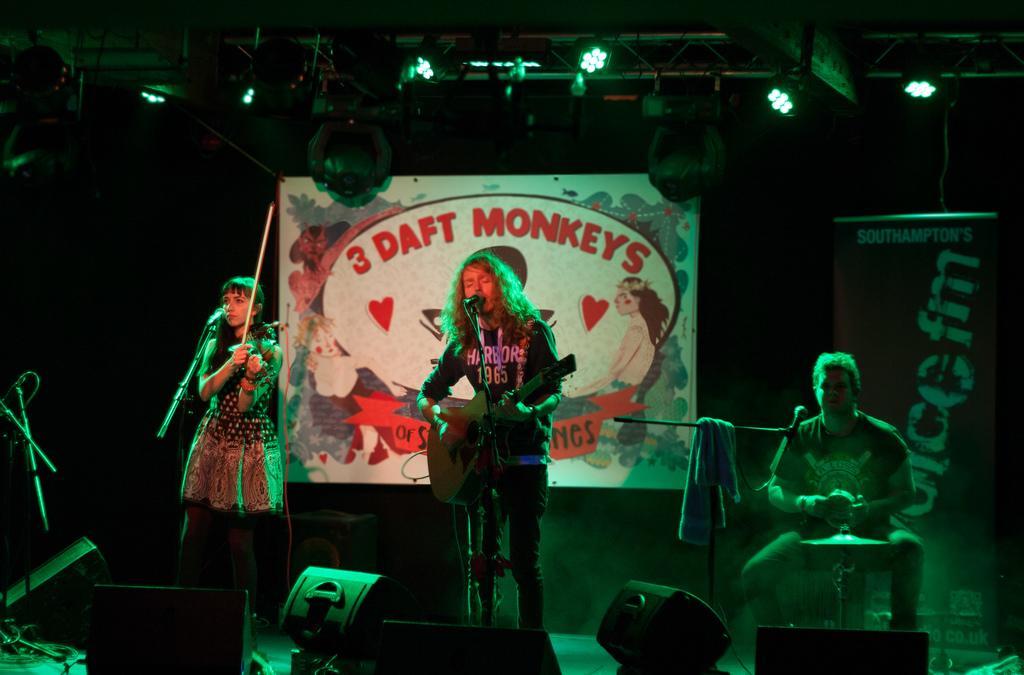Could you give a brief overview of what you see in this image? In this picture I can see 2 men and a woman who are holding musical instruments in their hands and I see mice in front of them. In the background I see the boards on which there is something written and on the top I see the lights. 